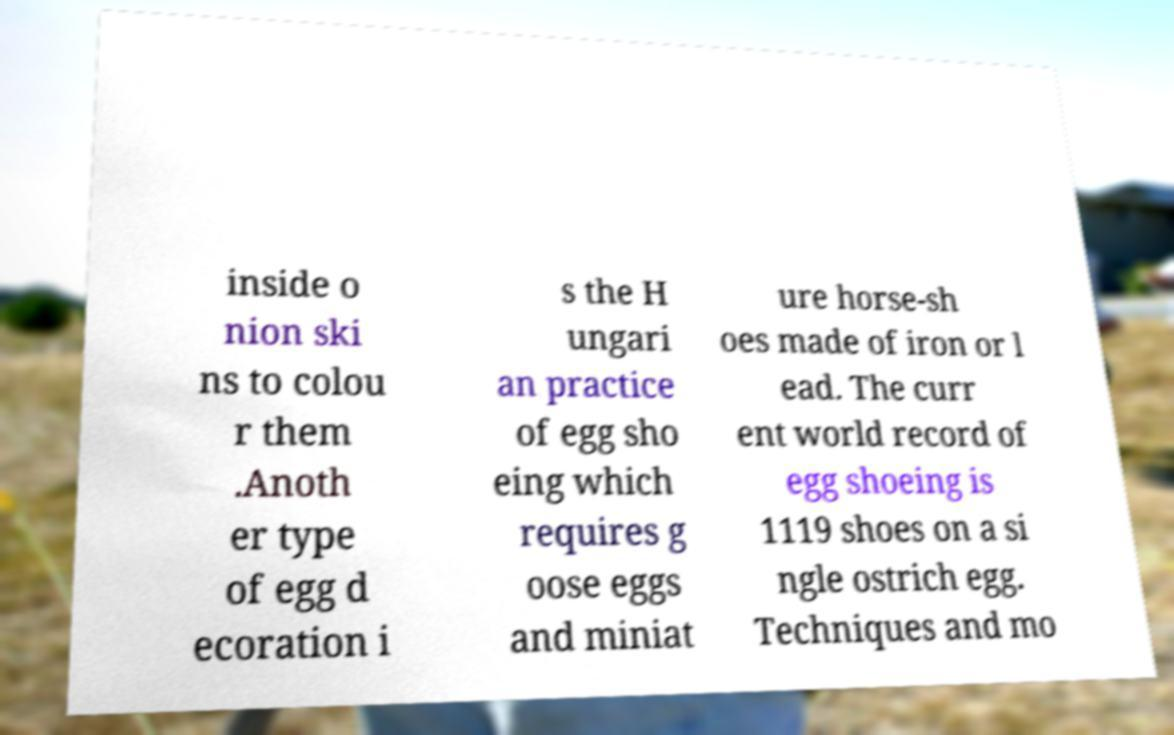Please read and relay the text visible in this image. What does it say? inside o nion ski ns to colou r them .Anoth er type of egg d ecoration i s the H ungari an practice of egg sho eing which requires g oose eggs and miniat ure horse-sh oes made of iron or l ead. The curr ent world record of egg shoeing is 1119 shoes on a si ngle ostrich egg. Techniques and mo 